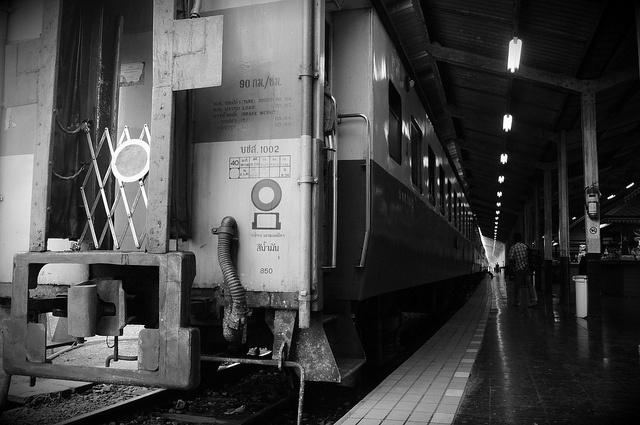Describe the objects in this image and their specific colors. I can see train in black, darkgray, gray, and lightgray tones and people in black and gray tones in this image. 